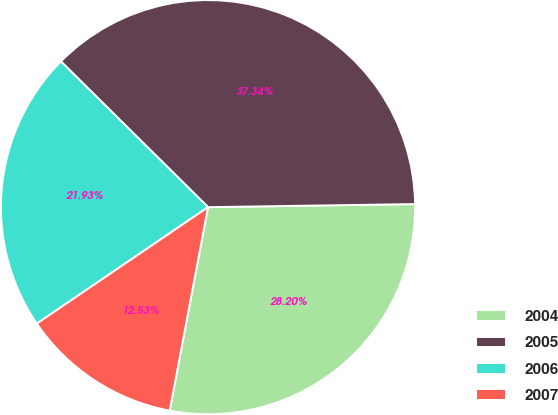Convert chart to OTSL. <chart><loc_0><loc_0><loc_500><loc_500><pie_chart><fcel>2004<fcel>2005<fcel>2006<fcel>2007<nl><fcel>28.2%<fcel>37.34%<fcel>21.93%<fcel>12.53%<nl></chart> 